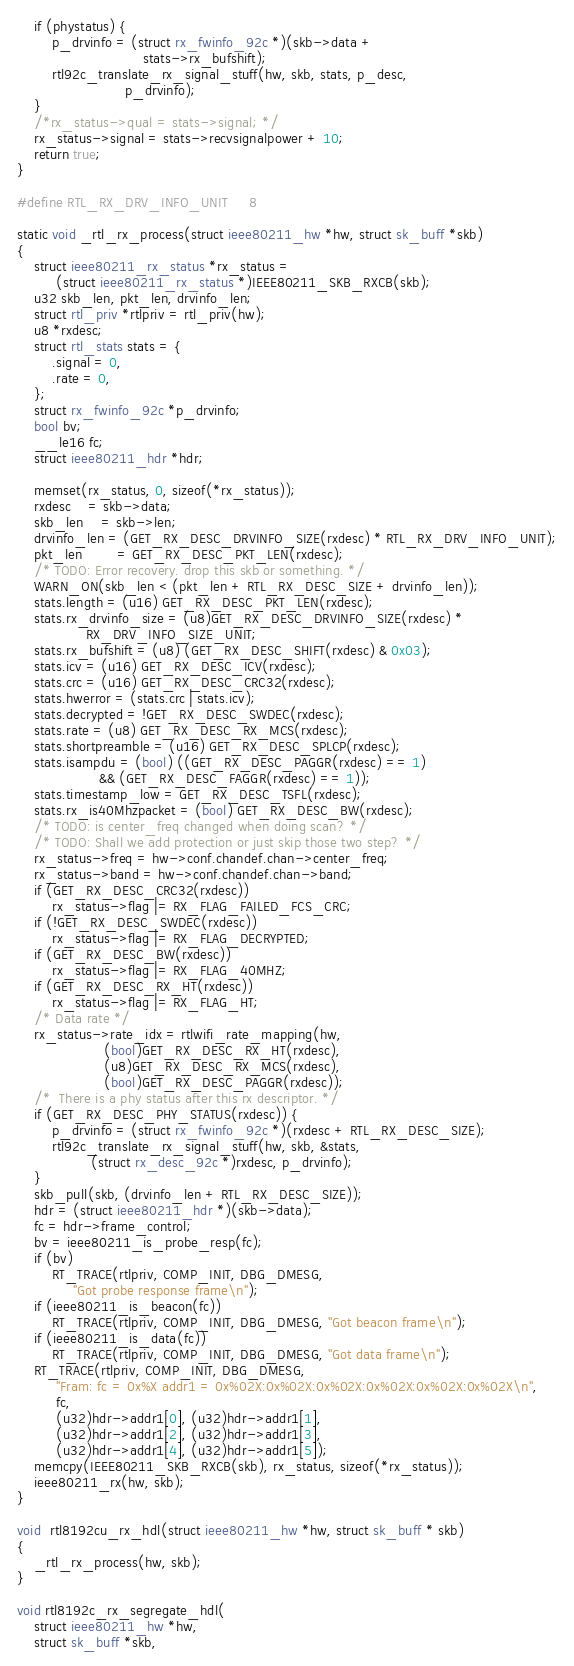Convert code to text. <code><loc_0><loc_0><loc_500><loc_500><_C_>	if (phystatus) {
		p_drvinfo = (struct rx_fwinfo_92c *)(skb->data +
						     stats->rx_bufshift);
		rtl92c_translate_rx_signal_stuff(hw, skb, stats, p_desc,
						 p_drvinfo);
	}
	/*rx_status->qual = stats->signal; */
	rx_status->signal = stats->recvsignalpower + 10;
	return true;
}

#define RTL_RX_DRV_INFO_UNIT		8

static void _rtl_rx_process(struct ieee80211_hw *hw, struct sk_buff *skb)
{
	struct ieee80211_rx_status *rx_status =
		 (struct ieee80211_rx_status *)IEEE80211_SKB_RXCB(skb);
	u32 skb_len, pkt_len, drvinfo_len;
	struct rtl_priv *rtlpriv = rtl_priv(hw);
	u8 *rxdesc;
	struct rtl_stats stats = {
		.signal = 0,
		.rate = 0,
	};
	struct rx_fwinfo_92c *p_drvinfo;
	bool bv;
	__le16 fc;
	struct ieee80211_hdr *hdr;

	memset(rx_status, 0, sizeof(*rx_status));
	rxdesc	= skb->data;
	skb_len	= skb->len;
	drvinfo_len = (GET_RX_DESC_DRVINFO_SIZE(rxdesc) * RTL_RX_DRV_INFO_UNIT);
	pkt_len		= GET_RX_DESC_PKT_LEN(rxdesc);
	/* TODO: Error recovery. drop this skb or something. */
	WARN_ON(skb_len < (pkt_len + RTL_RX_DESC_SIZE + drvinfo_len));
	stats.length = (u16) GET_RX_DESC_PKT_LEN(rxdesc);
	stats.rx_drvinfo_size = (u8)GET_RX_DESC_DRVINFO_SIZE(rxdesc) *
				RX_DRV_INFO_SIZE_UNIT;
	stats.rx_bufshift = (u8) (GET_RX_DESC_SHIFT(rxdesc) & 0x03);
	stats.icv = (u16) GET_RX_DESC_ICV(rxdesc);
	stats.crc = (u16) GET_RX_DESC_CRC32(rxdesc);
	stats.hwerror = (stats.crc | stats.icv);
	stats.decrypted = !GET_RX_DESC_SWDEC(rxdesc);
	stats.rate = (u8) GET_RX_DESC_RX_MCS(rxdesc);
	stats.shortpreamble = (u16) GET_RX_DESC_SPLCP(rxdesc);
	stats.isampdu = (bool) ((GET_RX_DESC_PAGGR(rxdesc) == 1)
				   && (GET_RX_DESC_FAGGR(rxdesc) == 1));
	stats.timestamp_low = GET_RX_DESC_TSFL(rxdesc);
	stats.rx_is40Mhzpacket = (bool) GET_RX_DESC_BW(rxdesc);
	/* TODO: is center_freq changed when doing scan? */
	/* TODO: Shall we add protection or just skip those two step? */
	rx_status->freq = hw->conf.chandef.chan->center_freq;
	rx_status->band = hw->conf.chandef.chan->band;
	if (GET_RX_DESC_CRC32(rxdesc))
		rx_status->flag |= RX_FLAG_FAILED_FCS_CRC;
	if (!GET_RX_DESC_SWDEC(rxdesc))
		rx_status->flag |= RX_FLAG_DECRYPTED;
	if (GET_RX_DESC_BW(rxdesc))
		rx_status->flag |= RX_FLAG_40MHZ;
	if (GET_RX_DESC_RX_HT(rxdesc))
		rx_status->flag |= RX_FLAG_HT;
	/* Data rate */
	rx_status->rate_idx = rtlwifi_rate_mapping(hw,
					(bool)GET_RX_DESC_RX_HT(rxdesc),
					(u8)GET_RX_DESC_RX_MCS(rxdesc),
					(bool)GET_RX_DESC_PAGGR(rxdesc));
	/*  There is a phy status after this rx descriptor. */
	if (GET_RX_DESC_PHY_STATUS(rxdesc)) {
		p_drvinfo = (struct rx_fwinfo_92c *)(rxdesc + RTL_RX_DESC_SIZE);
		rtl92c_translate_rx_signal_stuff(hw, skb, &stats,
				 (struct rx_desc_92c *)rxdesc, p_drvinfo);
	}
	skb_pull(skb, (drvinfo_len + RTL_RX_DESC_SIZE));
	hdr = (struct ieee80211_hdr *)(skb->data);
	fc = hdr->frame_control;
	bv = ieee80211_is_probe_resp(fc);
	if (bv)
		RT_TRACE(rtlpriv, COMP_INIT, DBG_DMESG,
			 "Got probe response frame\n");
	if (ieee80211_is_beacon(fc))
		RT_TRACE(rtlpriv, COMP_INIT, DBG_DMESG, "Got beacon frame\n");
	if (ieee80211_is_data(fc))
		RT_TRACE(rtlpriv, COMP_INIT, DBG_DMESG, "Got data frame\n");
	RT_TRACE(rtlpriv, COMP_INIT, DBG_DMESG,
		 "Fram: fc = 0x%X addr1 = 0x%02X:0x%02X:0x%02X:0x%02X:0x%02X:0x%02X\n",
		 fc,
		 (u32)hdr->addr1[0], (u32)hdr->addr1[1],
		 (u32)hdr->addr1[2], (u32)hdr->addr1[3],
		 (u32)hdr->addr1[4], (u32)hdr->addr1[5]);
	memcpy(IEEE80211_SKB_RXCB(skb), rx_status, sizeof(*rx_status));
	ieee80211_rx(hw, skb);
}

void  rtl8192cu_rx_hdl(struct ieee80211_hw *hw, struct sk_buff * skb)
{
	_rtl_rx_process(hw, skb);
}

void rtl8192c_rx_segregate_hdl(
	struct ieee80211_hw *hw,
	struct sk_buff *skb,</code> 